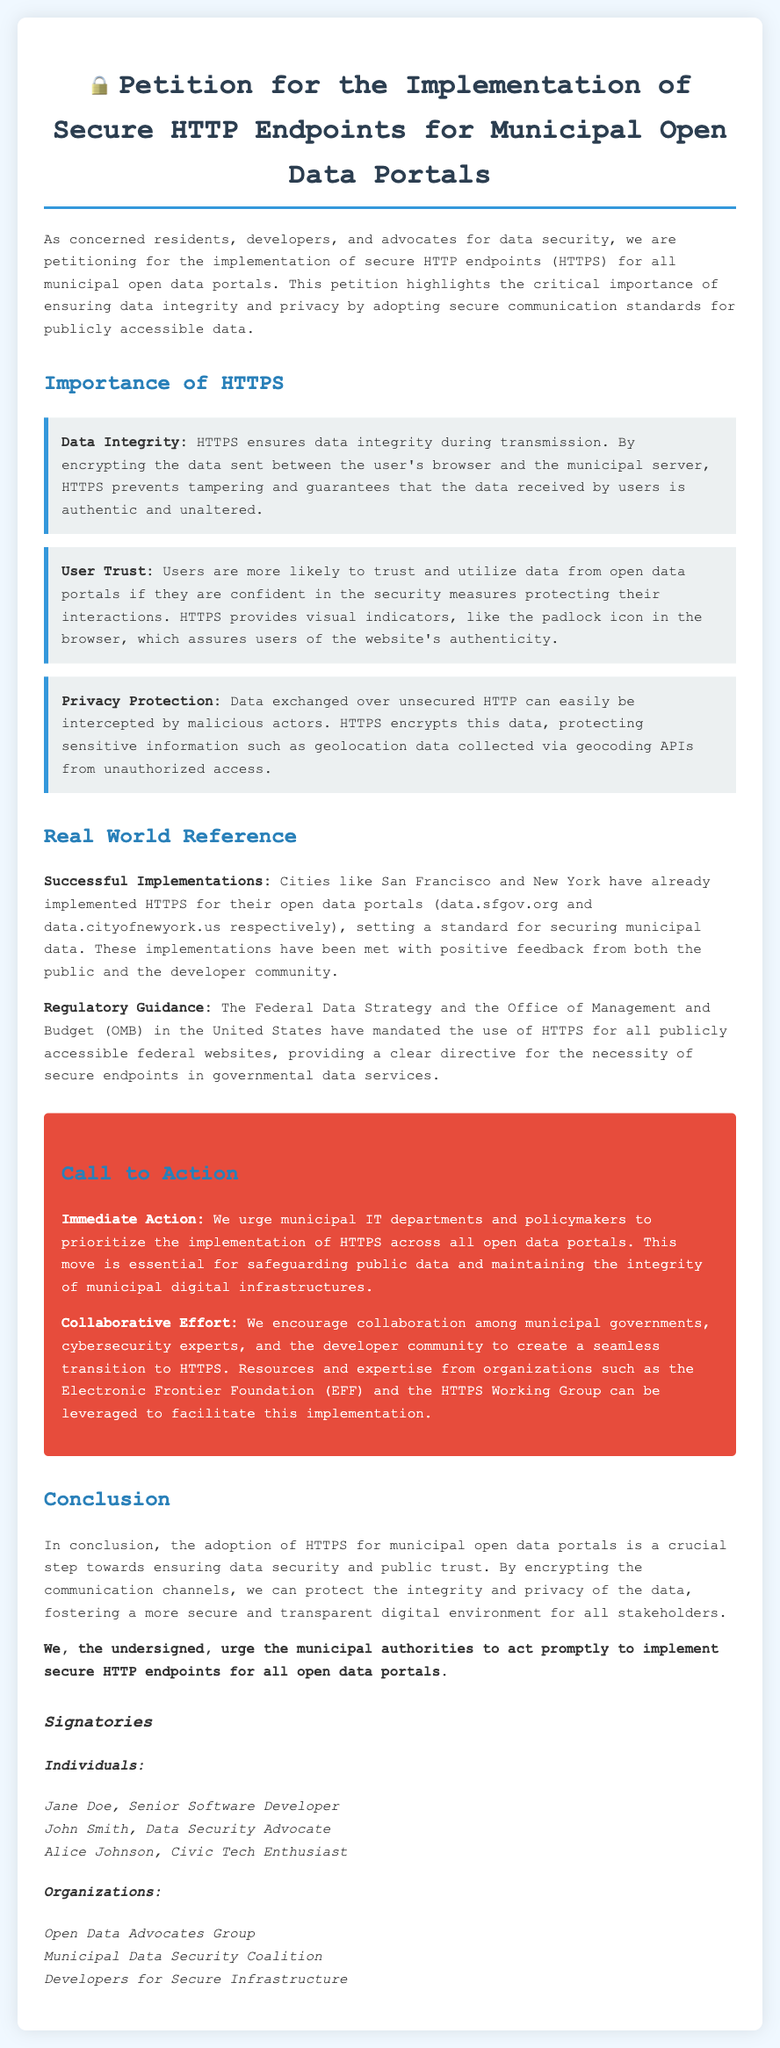What is the petition about? The petition calls for the implementation of secure HTTP endpoints for municipal open data portals to ensure data integrity and privacy.
Answer: Implementation of secure HTTP endpoints for municipal open data portals What does HTTPS ensure during transmission? HTTPS encrypts the data sent between the user's browser and the municipal server, preventing tampering.
Answer: Data integrity Which two cities are mentioned as having implemented HTTPS? San Francisco and New York are highlighted as cities that have successfully implemented HTTPS for their open data portals.
Answer: San Francisco and New York What is the call to action in the document? The document urges municipal IT departments and policymakers to prioritize the implementation of HTTPS across all open data portals.
Answer: Prioritize the implementation of HTTPS Who is the first individual listed as a signatory? The first signatory listed in the document is Jane Doe.
Answer: Jane Doe What does HTTPS provide to users that helps build trust? HTTPS provides visual indicators, like the padlock icon, assuring users of the website's authenticity.
Answer: Visual indicators What is one organization listed among the signatories? The Municipal Data Security Coalition is mentioned as one of the organizations that signed the petition.
Answer: Municipal Data Security Coalition What is the document's conclusion about HTTPS? The conclusion emphasizes that adopting HTTPS is crucial for ensuring data security and public trust.
Answer: Crucial step towards ensuring data security and public trust What agency mandated the use of HTTPS for federal websites? The Office of Management and Budget (OMB) mandated HTTPS for publicly accessible federal websites.
Answer: Office of Management and Budget (OMB) 